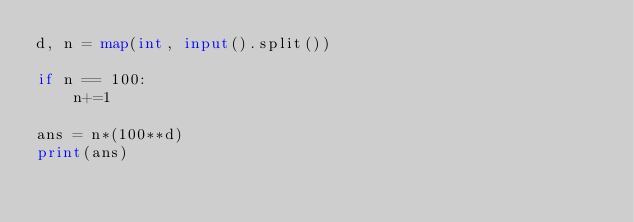Convert code to text. <code><loc_0><loc_0><loc_500><loc_500><_Python_>d, n = map(int, input().split())

if n == 100:
    n+=1

ans = n*(100**d)
print(ans)
</code> 